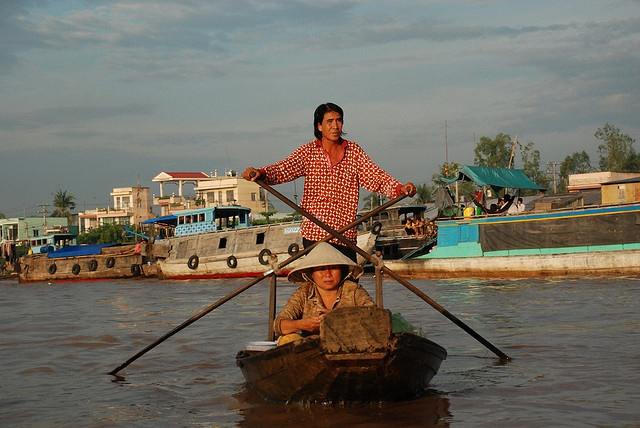Describe the objects in this image and their specific colors. I can see boat in gray, maroon, tan, and brown tones, boat in gray, black, maroon, and brown tones, people in gray, brown, maroon, and black tones, boat in gray, tan, and black tones, and people in gray, brown, maroon, black, and tan tones in this image. 